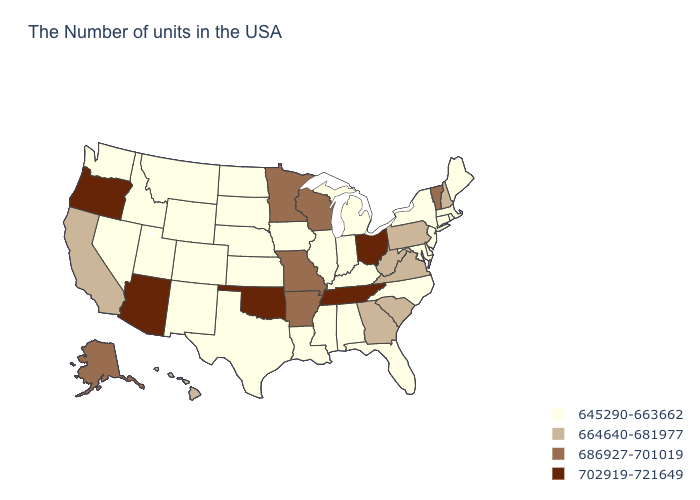Name the states that have a value in the range 702919-721649?
Write a very short answer. Ohio, Tennessee, Oklahoma, Arizona, Oregon. What is the lowest value in the MidWest?
Concise answer only. 645290-663662. How many symbols are there in the legend?
Quick response, please. 4. Name the states that have a value in the range 702919-721649?
Give a very brief answer. Ohio, Tennessee, Oklahoma, Arizona, Oregon. What is the lowest value in states that border Delaware?
Keep it brief. 645290-663662. Does Vermont have a higher value than Alabama?
Answer briefly. Yes. Does the map have missing data?
Be succinct. No. Which states have the lowest value in the USA?
Write a very short answer. Maine, Massachusetts, Rhode Island, Connecticut, New York, New Jersey, Delaware, Maryland, North Carolina, Florida, Michigan, Kentucky, Indiana, Alabama, Illinois, Mississippi, Louisiana, Iowa, Kansas, Nebraska, Texas, South Dakota, North Dakota, Wyoming, Colorado, New Mexico, Utah, Montana, Idaho, Nevada, Washington. Does Montana have the lowest value in the USA?
Answer briefly. Yes. What is the highest value in the USA?
Short answer required. 702919-721649. What is the value of Oregon?
Give a very brief answer. 702919-721649. What is the value of Missouri?
Give a very brief answer. 686927-701019. What is the highest value in the South ?
Be succinct. 702919-721649. Name the states that have a value in the range 664640-681977?
Give a very brief answer. New Hampshire, Pennsylvania, Virginia, South Carolina, West Virginia, Georgia, California, Hawaii. What is the lowest value in the South?
Answer briefly. 645290-663662. 